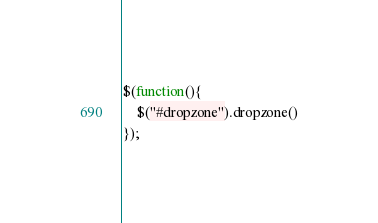Convert code to text. <code><loc_0><loc_0><loc_500><loc_500><_JavaScript_>$(function(){
	$("#dropzone").dropzone()
});</code> 